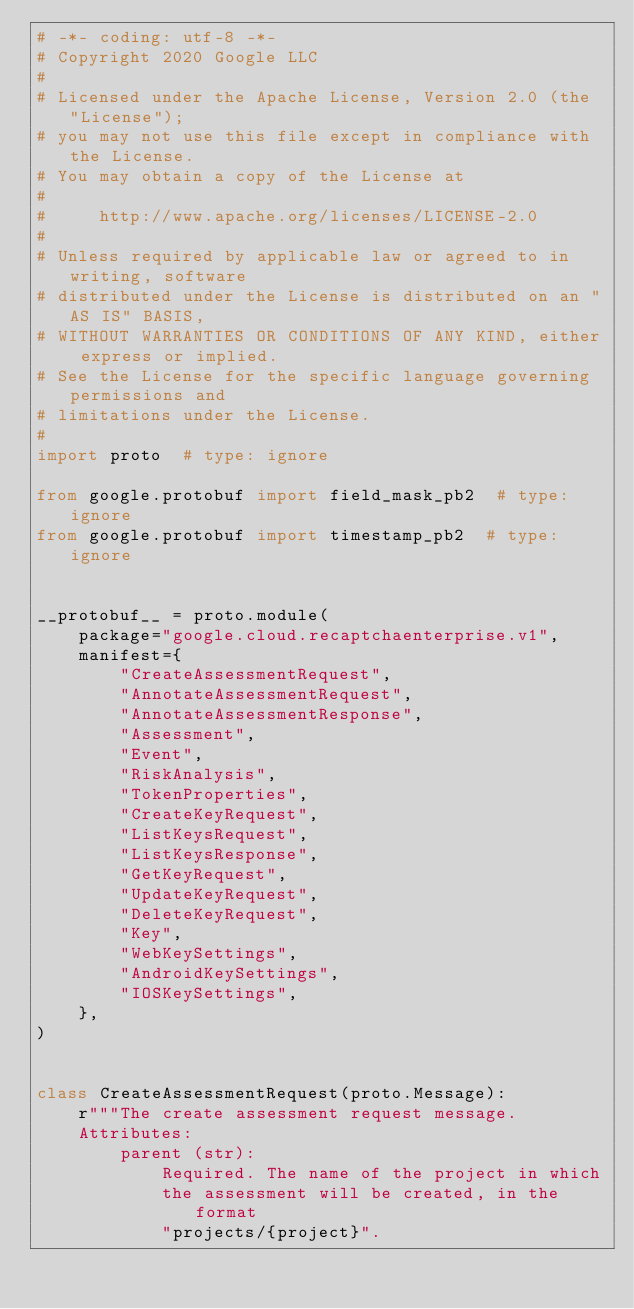<code> <loc_0><loc_0><loc_500><loc_500><_Python_># -*- coding: utf-8 -*-
# Copyright 2020 Google LLC
#
# Licensed under the Apache License, Version 2.0 (the "License");
# you may not use this file except in compliance with the License.
# You may obtain a copy of the License at
#
#     http://www.apache.org/licenses/LICENSE-2.0
#
# Unless required by applicable law or agreed to in writing, software
# distributed under the License is distributed on an "AS IS" BASIS,
# WITHOUT WARRANTIES OR CONDITIONS OF ANY KIND, either express or implied.
# See the License for the specific language governing permissions and
# limitations under the License.
#
import proto  # type: ignore

from google.protobuf import field_mask_pb2  # type: ignore
from google.protobuf import timestamp_pb2  # type: ignore


__protobuf__ = proto.module(
    package="google.cloud.recaptchaenterprise.v1",
    manifest={
        "CreateAssessmentRequest",
        "AnnotateAssessmentRequest",
        "AnnotateAssessmentResponse",
        "Assessment",
        "Event",
        "RiskAnalysis",
        "TokenProperties",
        "CreateKeyRequest",
        "ListKeysRequest",
        "ListKeysResponse",
        "GetKeyRequest",
        "UpdateKeyRequest",
        "DeleteKeyRequest",
        "Key",
        "WebKeySettings",
        "AndroidKeySettings",
        "IOSKeySettings",
    },
)


class CreateAssessmentRequest(proto.Message):
    r"""The create assessment request message.
    Attributes:
        parent (str):
            Required. The name of the project in which
            the assessment will be created, in the format
            "projects/{project}".</code> 